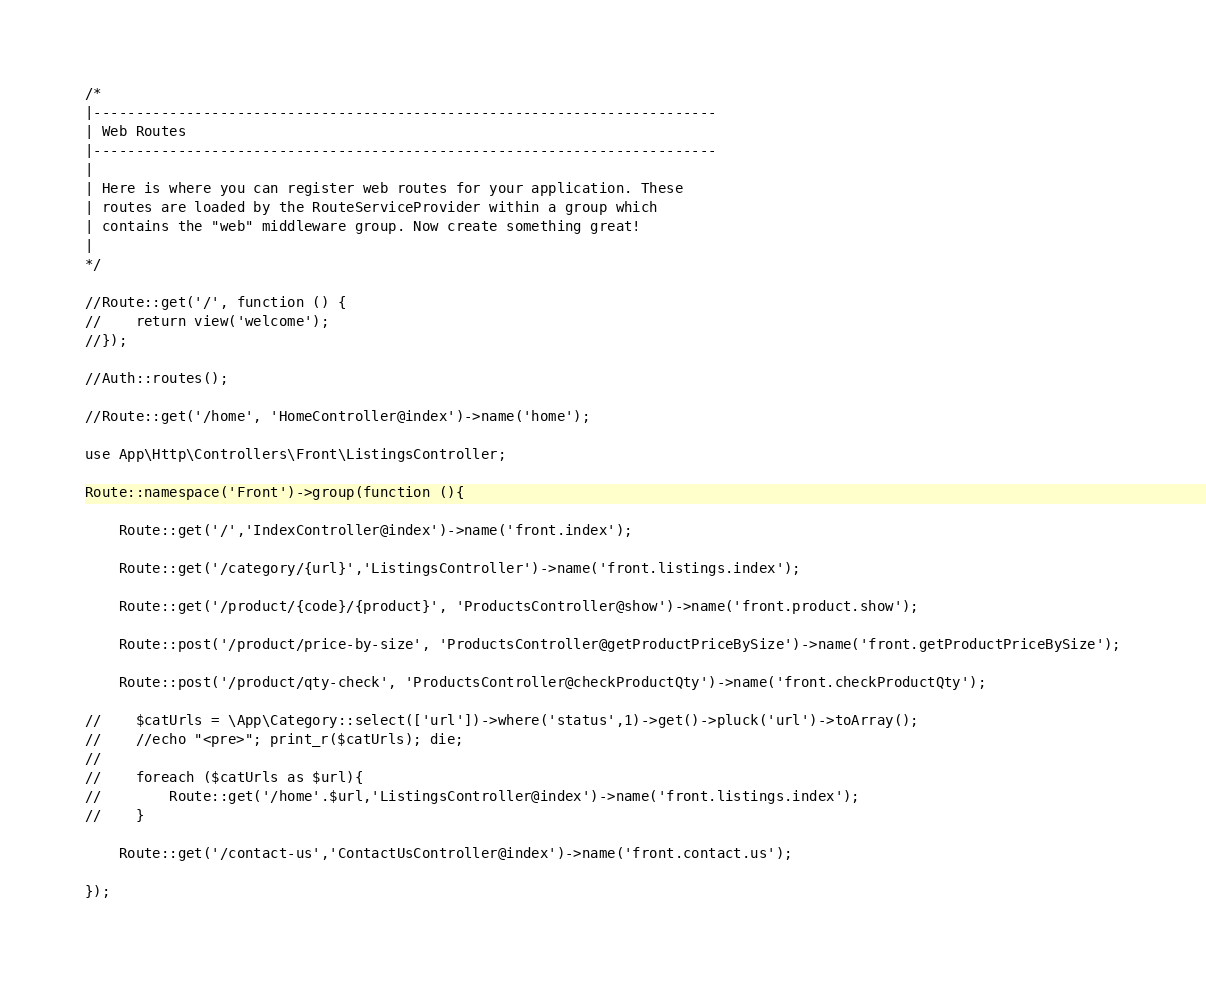Convert code to text. <code><loc_0><loc_0><loc_500><loc_500><_PHP_>
/*
|--------------------------------------------------------------------------
| Web Routes
|--------------------------------------------------------------------------
|
| Here is where you can register web routes for your application. These
| routes are loaded by the RouteServiceProvider within a group which
| contains the "web" middleware group. Now create something great!
|
*/

//Route::get('/', function () {
//    return view('welcome');
//});

//Auth::routes();

//Route::get('/home', 'HomeController@index')->name('home');

use App\Http\Controllers\Front\ListingsController;

Route::namespace('Front')->group(function (){

    Route::get('/','IndexController@index')->name('front.index');

    Route::get('/category/{url}','ListingsController')->name('front.listings.index');

    Route::get('/product/{code}/{product}', 'ProductsController@show')->name('front.product.show');

    Route::post('/product/price-by-size', 'ProductsController@getProductPriceBySize')->name('front.getProductPriceBySize');

    Route::post('/product/qty-check', 'ProductsController@checkProductQty')->name('front.checkProductQty');

//    $catUrls = \App\Category::select(['url'])->where('status',1)->get()->pluck('url')->toArray();
//    //echo "<pre>"; print_r($catUrls); die;
//
//    foreach ($catUrls as $url){
//        Route::get('/home'.$url,'ListingsController@index')->name('front.listings.index');
//    }

    Route::get('/contact-us','ContactUsController@index')->name('front.contact.us');

});

</code> 